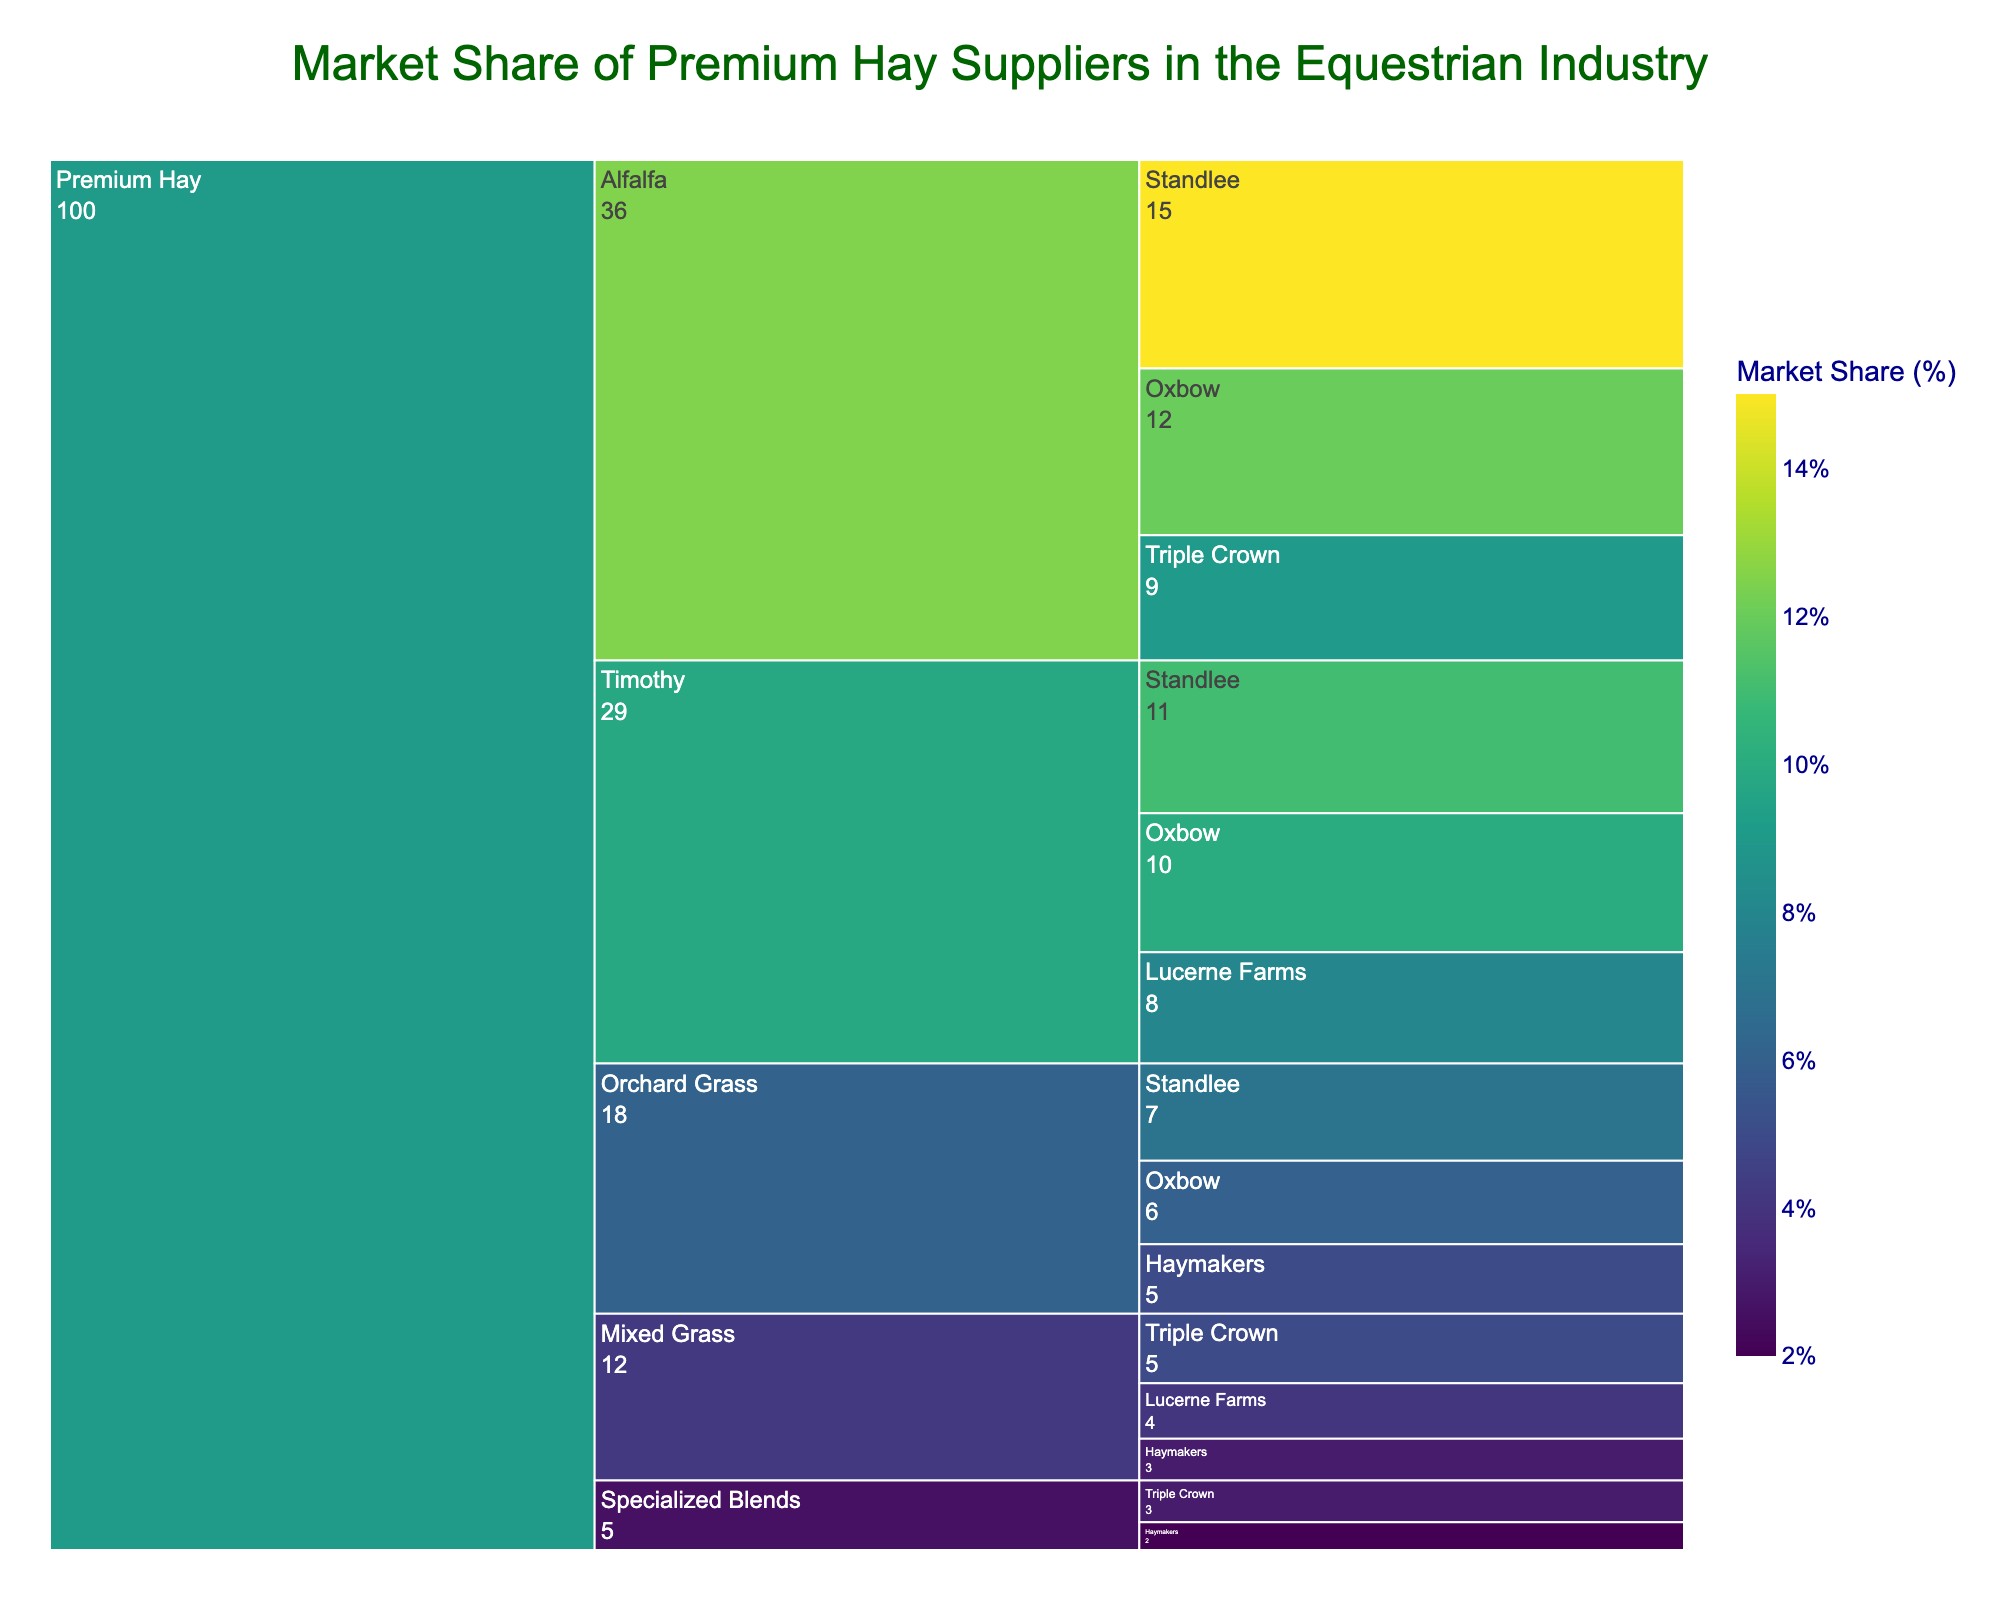What's the market share of Standlee in the Premium Hay category? Look at the segments with the highest market share labeled under "Premium Hay," and sum up the market shares from Standlee in different subcategories: Alfalfa (15%), Timothy (11%), Orchard Grass (7%). The total is 15% + 11% + 7% = 33%
Answer: 33% Which subcategory has the highest market share for the Alfalfa category? In the Alfalfa category, compare the market shares of Standlee (15%), Oxbow (12%), and Triple Crown (9%). Standlee has the highest market share with 15%.
Answer: Standlee What's the combined market share of Oxbow across all subcategories? Add the market shares of Oxbow in all subcategories: Alfalfa (12%), Timothy (10%), and Orchard Grass (6%). The total is 12% + 10% + 6% = 28%
Answer: 28% Among all brands in the Timothy subcategory, which brand has the smallest market share? Look at the Timothy subcategory and compare the market shares: Standlee (11%), Oxbow (10%), Lucerne Farms (8%). Lucerne Farms has the smallest share with 8%
Answer: Lucerne Farms Which subcategory under Premium Hay has the lowest total market share? Sum the market shares for each subcategory:
- Alfalfa: 15% + 12% + 9% = 36%
- Timothy: 11% + 10% + 8% = 29%
- Orchard Grass: 7% + 6% + 5% = 18%
- Mixed Grass: 5% + 4% + 3% = 12%
- Specialized Blends: 3% + 2% = 5%
Specialized Blends has the lowest share with 5%
Answer: Specialized Blends Compare the market shares of Triple Crown and Haymakers in the Mixed Grass category. Triple Crown has a market share of 5% in Mixed Grass, while Haymakers has 3%. Compare them: 5% > 3%, so Triple Crown has a higher market share.
Answer: Triple Crown How does Standlee's market share in Timothy compare to its market share in Orchard Grass? Standlee's market share in Timothy is 11%, while in Orchard Grass it is 7%. Compare them: 11% > 7%, so Standlee's share is higher in Timothy.
Answer: Higher in Timothy What is the total market share for brands under Orchard Grass? Sum the market shares of brands under Orchard Grass: Standlee (7%), Oxbow (6%), and Haymakers (5%). Total is 7% + 6% + 5% = 18%
Answer: 18% Is the market share of Standlee in Alfalfa greater than the market share of Triple Crown in Alfalfa? Standlee's market share in Alfalfa is 15%, and Triple Crown's is 9%. Compare them: 15% > 9%, so it is greater.
Answer: Yes 